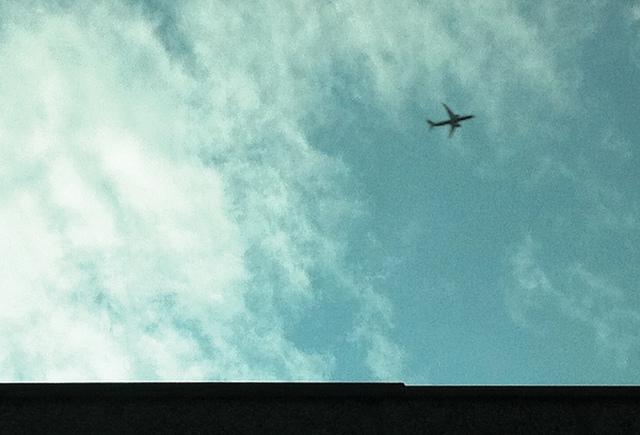Can this plane land on water?
Keep it brief. No. Is the plane in the air?
Quick response, please. Yes. Are there any clouds in the sky?
Short answer required. Yes. Is this sand?
Answer briefly. No. What direction is the sunlight coming from?
Give a very brief answer. Left. What is in the sky?
Concise answer only. Airplane. Are they performing an air show?
Concise answer only. No. Is the sky blue?
Concise answer only. Yes. What is the Black bar on the bottom of the screen?
Answer briefly. Crop. Can you see any plants?
Short answer required. No. Which company operates this plane?
Concise answer only. Boeing. How many birds are flying?
Answer briefly. 0. Is there texture in the scene?
Concise answer only. Yes. 